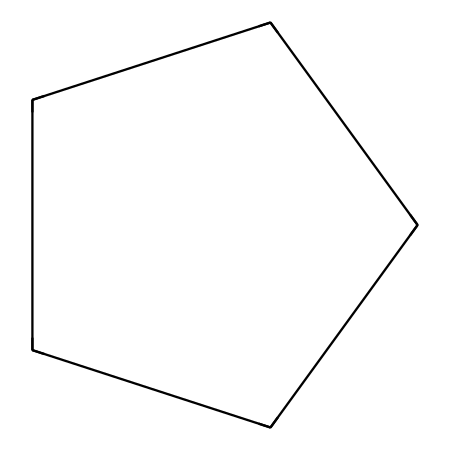What is the molecular formula of cyclopentane? The SMILES representation shows five carbon atoms connected in a cycle. Each carbon, along with hydrogens, corresponds to the chemical formula C5H10, since each carbon typically bonds with two hydrogen atoms (with tweaks for bonding).
Answer: C5H10 How many carbon atoms are in cyclopentane? By examining the SMILES structure, there are five 'C' characters indicating that there are five carbon atoms in the molecule.
Answer: 5 What type of structure does cyclopentane have? Cyclopentane has a cyclic structure, as it is a cycloalkane, which is indicated by the '1' in the SMILES notation that shows the closure of the carbon ring.
Answer: cyclic What is the total number of hydrogen atoms in cyclopentane? Each carbon in cyclopentane is attached to two hydrogens, totaling 10 hydrogen atoms (5 carbons x 2 hydrogens). The extra hydrogens come from the nature of cycloalkanes having fewer hydrogens due to ring closure, making it count to 10.
Answer: 10 What is the main chemical category of cyclopentane? Cyclopentane falls under the category of cycloalkanes as it is a cyclic and saturated hydrocarbon with single bonds.
Answer: cycloalkane What physical state is cyclopentane typically found in at room temperature? Generally, cyclopentane is a liquid at room temperature, which is commonly known for its low boiling point, indicative of the molecular interactions present.
Answer: liquid Why is cyclopentane used in medical-grade adhesives? Cyclopentane contributes to adhesive properties due to its structure which allows flexibility and stability in formulations, especially for skin applications.
Answer: flexibility 